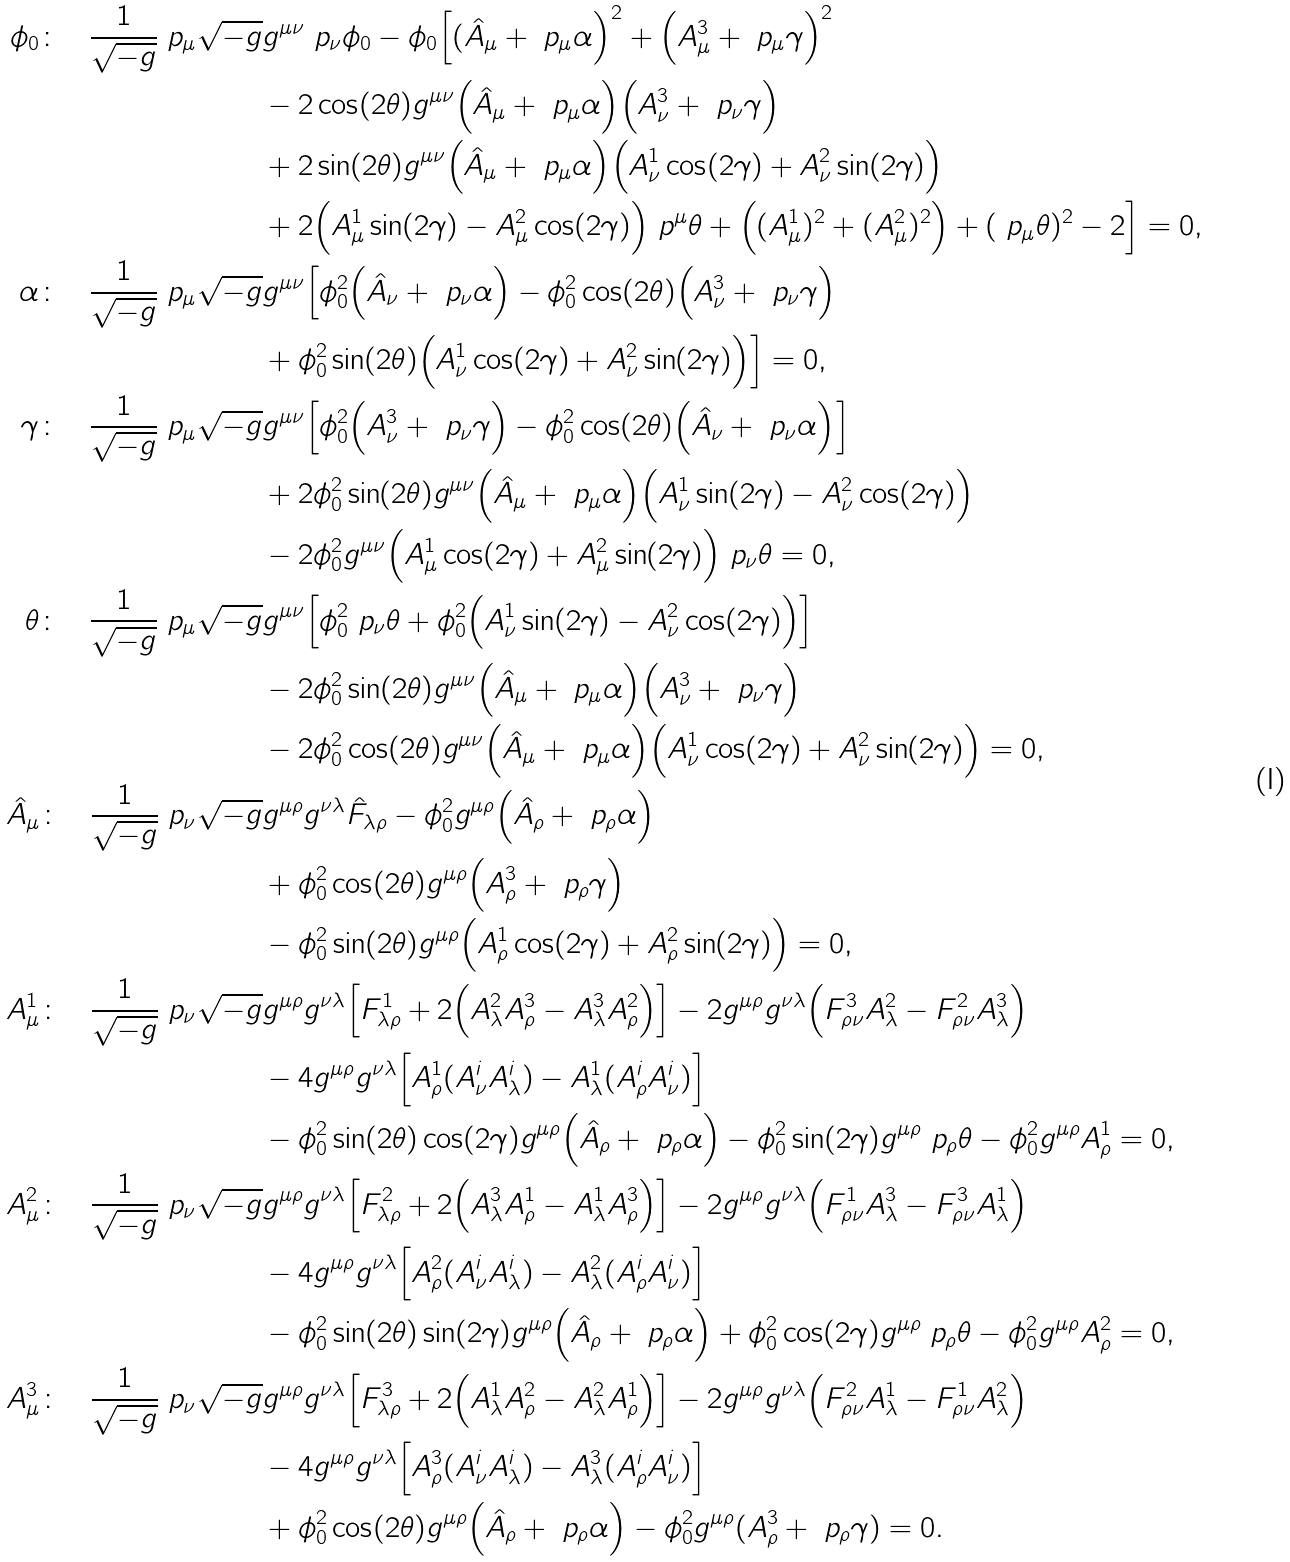Convert formula to latex. <formula><loc_0><loc_0><loc_500><loc_500>\phi _ { 0 } \colon \quad \frac { 1 } { \sqrt { - g } } \ p _ { \mu } \sqrt { - g } & g ^ { \mu \nu } \ p _ { \nu } \phi _ { 0 } - \phi _ { 0 } \Big [ ( \hat { A } _ { \mu } + \ p _ { \mu } \alpha \Big ) ^ { 2 } + \Big ( A _ { \mu } ^ { 3 } + \ p _ { \mu } \gamma \Big ) ^ { 2 } \\ & - 2 \cos ( 2 \theta ) g ^ { \mu \nu } \Big ( \hat { A } _ { \mu } + \ p _ { \mu } \alpha \Big ) \Big ( A ^ { 3 } _ { \nu } + \ p _ { \nu } \gamma \Big ) \\ & + 2 \sin ( 2 \theta ) g ^ { \mu \nu } \Big ( \hat { A } _ { \mu } + \ p _ { \mu } \alpha \Big ) \Big ( A _ { \nu } ^ { 1 } \cos ( 2 \gamma ) + A _ { \nu } ^ { 2 } \sin ( 2 \gamma ) \Big ) \\ & + 2 \Big ( A _ { \mu } ^ { 1 } \sin ( 2 \gamma ) - A _ { \mu } ^ { 2 } \cos ( 2 \gamma ) \Big ) \ p ^ { \mu } \theta + \Big ( ( A ^ { 1 } _ { \mu } ) ^ { 2 } + ( A ^ { 2 } _ { \mu } ) ^ { 2 } \Big ) + ( \ p _ { \mu } \theta ) ^ { 2 } - 2 \Big ] = 0 , \\ \alpha \colon \quad \frac { 1 } { \sqrt { - g } } \ p _ { \mu } \sqrt { - g } & g ^ { \mu \nu } \Big [ \phi _ { 0 } ^ { 2 } \Big ( \hat { A } _ { \nu } + \ p _ { \nu } \alpha \Big ) - \phi _ { 0 } ^ { 2 } \cos ( 2 \theta ) \Big ( A ^ { 3 } _ { \nu } + \ p _ { \nu } \gamma \Big ) \\ & + \phi _ { 0 } ^ { 2 } \sin ( 2 \theta ) \Big ( A _ { \nu } ^ { 1 } \cos ( 2 \gamma ) + A _ { \nu } ^ { 2 } \sin ( 2 \gamma ) \Big ) \Big ] = 0 , \\ \gamma \colon \quad \frac { 1 } { \sqrt { - g } } \ p _ { \mu } \sqrt { - g } & g ^ { \mu \nu } \Big [ \phi _ { 0 } ^ { 2 } \Big ( A ^ { 3 } _ { \nu } + \ p _ { \nu } \gamma \Big ) - \phi _ { 0 } ^ { 2 } \cos ( 2 \theta ) \Big ( \hat { A } _ { \nu } + \ p _ { \nu } \alpha \Big ) \Big ] \\ & + 2 \phi _ { 0 } ^ { 2 } \sin ( 2 \theta ) g ^ { \mu \nu } \Big ( \hat { A } _ { \mu } + \ p _ { \mu } \alpha \Big ) \Big ( A _ { \nu } ^ { 1 } \sin ( 2 \gamma ) - A _ { \nu } ^ { 2 } \cos ( 2 \gamma ) \Big ) \\ & - 2 \phi _ { 0 } ^ { 2 } g ^ { \mu \nu } \Big ( A _ { \mu } ^ { 1 } \cos ( 2 \gamma ) + A _ { \mu } ^ { 2 } \sin ( 2 \gamma ) \Big ) \ p _ { \nu } \theta = 0 , \\ \theta \colon \quad \frac { 1 } { \sqrt { - g } } \ p _ { \mu } \sqrt { - g } & g ^ { \mu \nu } \Big [ \phi _ { 0 } ^ { 2 } \ p _ { \nu } \theta + \phi _ { 0 } ^ { 2 } \Big ( A _ { \nu } ^ { 1 } \sin ( 2 \gamma ) - A _ { \nu } ^ { 2 } \cos ( 2 \gamma ) \Big ) \Big ] \\ & - 2 \phi _ { 0 } ^ { 2 } \sin ( 2 \theta ) g ^ { \mu \nu } \Big ( \hat { A } _ { \mu } + \ p _ { \mu } \alpha \Big ) \Big ( A ^ { 3 } _ { \nu } + \ p _ { \nu } \gamma \Big ) \\ & - 2 \phi _ { 0 } ^ { 2 } \cos ( 2 \theta ) g ^ { \mu \nu } \Big ( \hat { A } _ { \mu } + \ p _ { \mu } \alpha \Big ) \Big ( A _ { \nu } ^ { 1 } \cos ( 2 \gamma ) + A _ { \nu } ^ { 2 } \sin ( 2 \gamma ) \Big ) = 0 , \\ \hat { A } _ { \mu } \colon \quad \frac { 1 } { \sqrt { - g } } \ p _ { \nu } \sqrt { - g } & g ^ { \mu \rho } g ^ { \nu \lambda } \hat { F } _ { \lambda \rho } - \phi _ { 0 } ^ { 2 } g ^ { \mu \rho } \Big ( \hat { A } _ { \rho } + \ p _ { \rho } \alpha \Big ) \\ & + \phi _ { 0 } ^ { 2 } \cos ( 2 \theta ) g ^ { \mu \rho } \Big ( A ^ { 3 } _ { \rho } + \ p _ { \rho } \gamma \Big ) \\ & - \phi _ { 0 } ^ { 2 } \sin ( 2 \theta ) g ^ { \mu \rho } \Big ( A _ { \rho } ^ { 1 } \cos ( 2 \gamma ) + A _ { \rho } ^ { 2 } \sin ( 2 \gamma ) \Big ) = 0 , \\ A ^ { 1 } _ { \mu } \colon \quad \frac { 1 } { \sqrt { - g } } \ p _ { \nu } \sqrt { - g } & g ^ { \mu \rho } g ^ { \nu \lambda } \Big [ F ^ { 1 } _ { \lambda \rho } + 2 \Big ( A ^ { 2 } _ { \lambda } A ^ { 3 } _ { \rho } - A ^ { 3 } _ { \lambda } A ^ { 2 } _ { \rho } \Big ) \Big ] - 2 g ^ { \mu \rho } g ^ { \nu \lambda } \Big ( F ^ { 3 } _ { \rho \nu } A ^ { 2 } _ { \lambda } - F ^ { 2 } _ { \rho \nu } A ^ { 3 } _ { \lambda } \Big ) \\ & - 4 g ^ { \mu \rho } g ^ { \nu \lambda } \Big [ A _ { \rho } ^ { 1 } ( A _ { \nu } ^ { i } A _ { \lambda } ^ { i } ) - A _ { \lambda } ^ { 1 } ( A _ { \rho } ^ { i } A _ { \nu } ^ { i } ) \Big ] \\ & - \phi _ { 0 } ^ { 2 } \sin ( 2 \theta ) \cos ( 2 \gamma ) g ^ { \mu \rho } \Big ( \hat { A } _ { \rho } + \ p _ { \rho } \alpha \Big ) - \phi _ { 0 } ^ { 2 } \sin ( 2 \gamma ) g ^ { \mu \rho } \ p _ { \rho } \theta - \phi _ { 0 } ^ { 2 } g ^ { \mu \rho } A ^ { 1 } _ { \rho } = 0 , \\ A ^ { 2 } _ { \mu } \colon \quad \frac { 1 } { \sqrt { - g } } \ p _ { \nu } \sqrt { - g } & g ^ { \mu \rho } g ^ { \nu \lambda } \Big [ F ^ { 2 } _ { \lambda \rho } + 2 \Big ( A ^ { 3 } _ { \lambda } A ^ { 1 } _ { \rho } - A ^ { 1 } _ { \lambda } A ^ { 3 } _ { \rho } \Big ) \Big ] - 2 g ^ { \mu \rho } g ^ { \nu \lambda } \Big ( F ^ { 1 } _ { \rho \nu } A ^ { 3 } _ { \lambda } - F ^ { 3 } _ { \rho \nu } A ^ { 1 } _ { \lambda } \Big ) \\ & - 4 g ^ { \mu \rho } g ^ { \nu \lambda } \Big [ A _ { \rho } ^ { 2 } ( A _ { \nu } ^ { i } A _ { \lambda } ^ { i } ) - A _ { \lambda } ^ { 2 } ( A _ { \rho } ^ { i } A _ { \nu } ^ { i } ) \Big ] \\ & - \phi _ { 0 } ^ { 2 } \sin ( 2 \theta ) \sin ( 2 \gamma ) g ^ { \mu \rho } \Big ( \hat { A } _ { \rho } + \ p _ { \rho } \alpha \Big ) + \phi _ { 0 } ^ { 2 } \cos ( 2 \gamma ) g ^ { \mu \rho } \ p _ { \rho } \theta - \phi _ { 0 } ^ { 2 } g ^ { \mu \rho } A ^ { 2 } _ { \rho } = 0 , \\ A ^ { 3 } _ { \mu } \colon \quad \frac { 1 } { \sqrt { - g } } \ p _ { \nu } \sqrt { - g } & g ^ { \mu \rho } g ^ { \nu \lambda } \Big [ F ^ { 3 } _ { \lambda \rho } + 2 \Big ( A ^ { 1 } _ { \lambda } A ^ { 2 } _ { \rho } - A ^ { 2 } _ { \lambda } A ^ { 1 } _ { \rho } \Big ) \Big ] - 2 g ^ { \mu \rho } g ^ { \nu \lambda } \Big ( F ^ { 2 } _ { \rho \nu } A ^ { 1 } _ { \lambda } - F ^ { 1 } _ { \rho \nu } A ^ { 2 } _ { \lambda } \Big ) \\ & - 4 g ^ { \mu \rho } g ^ { \nu \lambda } \Big [ A _ { \rho } ^ { 3 } ( A _ { \nu } ^ { i } A _ { \lambda } ^ { i } ) - A _ { \lambda } ^ { 3 } ( A _ { \rho } ^ { i } A _ { \nu } ^ { i } ) \Big ] \\ & + \phi _ { 0 } ^ { 2 } \cos ( 2 \theta ) g ^ { \mu \rho } \Big ( \hat { A } _ { \rho } + \ p _ { \rho } \alpha \Big ) - \phi _ { 0 } ^ { 2 } g ^ { \mu \rho } ( A ^ { 3 } _ { \rho } + \ p _ { \rho } \gamma ) = 0 .</formula> 